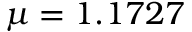Convert formula to latex. <formula><loc_0><loc_0><loc_500><loc_500>\mu = 1 . 1 7 2 7</formula> 